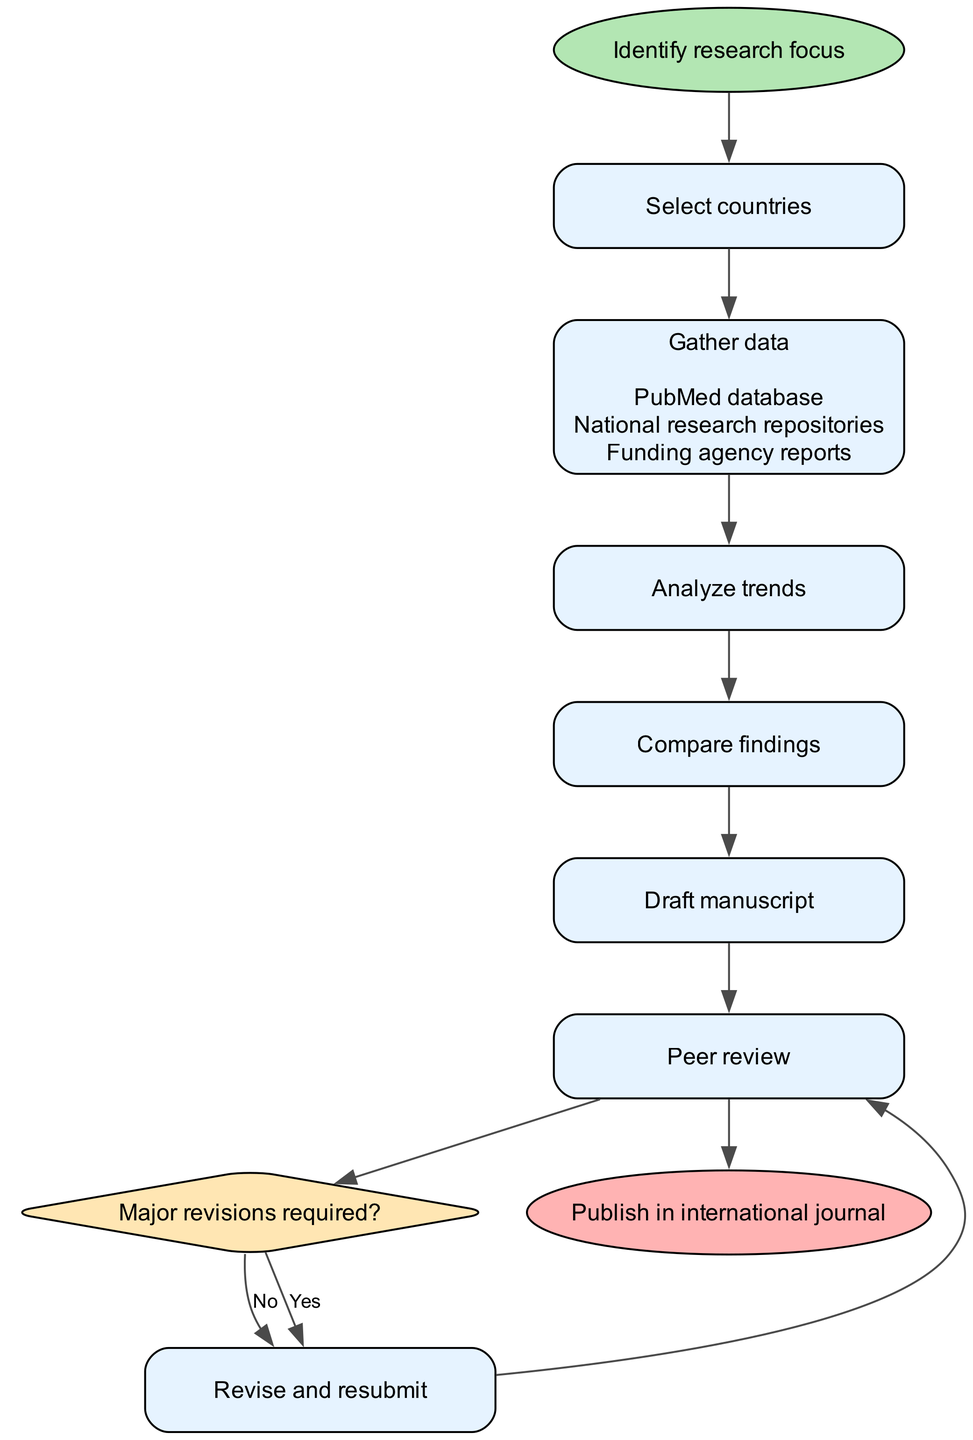What's the first step in the diagram? The diagram begins with the "Identify research focus" node, which indicates that identifying the research focus is the very first action in the process.
Answer: Identify research focus How many steps are there before the 'Peer review' step? Counting from 'Select countries' to 'Peer review', there are four steps before reaching 'Peer review'. Those steps are 'Select countries', 'Gather data', 'Analyze trends', and 'Compare findings'.
Answer: Four What is the last step in the process? The final node of the diagram represents the end point, which is "Publish in international journal", indicating this is the last action taken after completion of all previous steps.
Answer: Publish in international journal What decision must be made after the 'Peer review'? After 'Peer review', the decision is whether 'Major revisions required?', indicating that the author needs to assess if major changes are necessary before proceeding further.
Answer: Major revisions required? Which node follows 'Analyze trends'? According to the flow of the diagram, 'Analyze trends' is directly followed by the 'Compare findings' node, signifying the next action after analyzing the gathered data.
Answer: Compare findings If major revisions are required, which step comes next? If it is determined that major revisions are required, the next step would lead back to 'Revise and resubmit', as indicated by the decision node which routes to this action in case of a 'Yes'.
Answer: Revise and resubmit What details are associated with the 'Gather data' step? The 'Gather data' step has three associated details: "PubMed database", "National research repositories", and "Funding agency reports", which outline the sources for data gathering.
Answer: PubMed database, National research repositories, Funding agency reports How many edges are connected to the 'Draft manuscript' step? The 'Draft manuscript' step is connected by one edge leading to 'Peer review', indicating that it moves directly into this next step without further conditions or branches.
Answer: One edge 